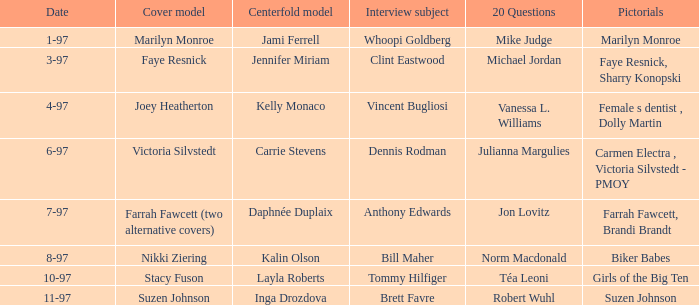Who was the focal model when a pictorial presentation was made on marilyn monroe? Jami Ferrell. 